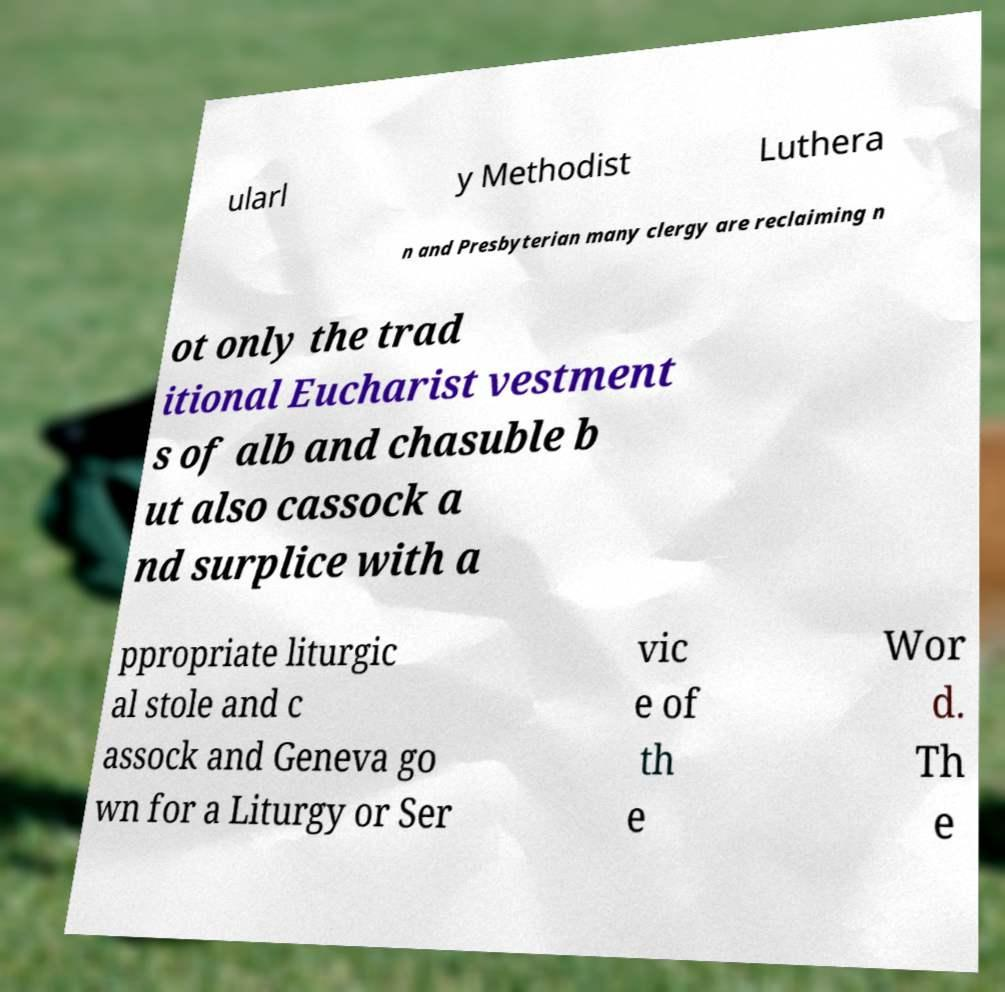Please identify and transcribe the text found in this image. ularl y Methodist Luthera n and Presbyterian many clergy are reclaiming n ot only the trad itional Eucharist vestment s of alb and chasuble b ut also cassock a nd surplice with a ppropriate liturgic al stole and c assock and Geneva go wn for a Liturgy or Ser vic e of th e Wor d. Th e 